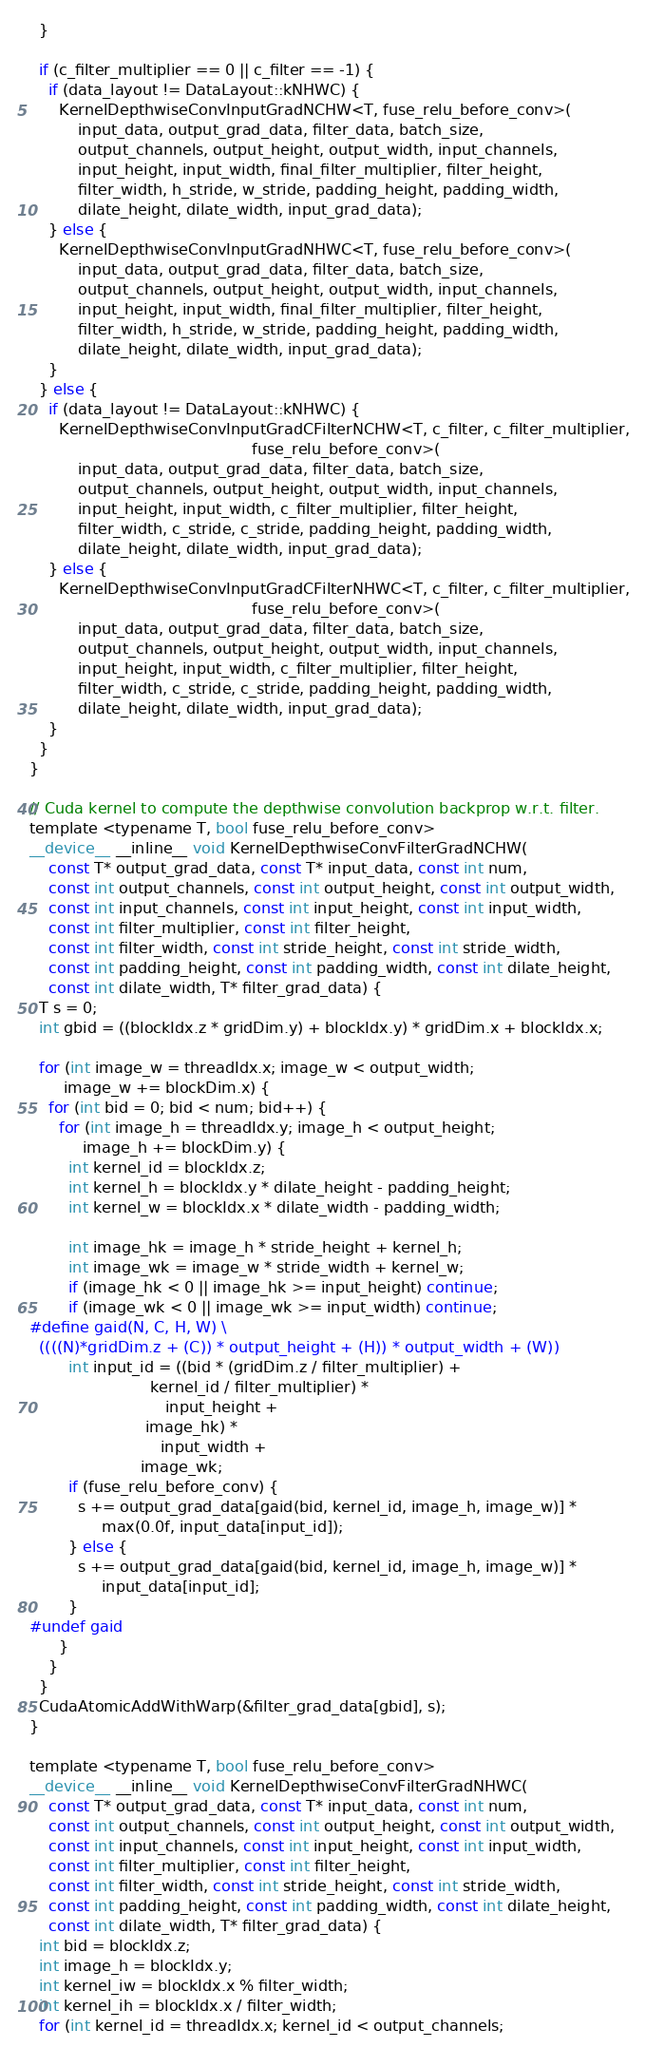<code> <loc_0><loc_0><loc_500><loc_500><_Cuda_>  }

  if (c_filter_multiplier == 0 || c_filter == -1) {
    if (data_layout != DataLayout::kNHWC) {
      KernelDepthwiseConvInputGradNCHW<T, fuse_relu_before_conv>(
          input_data, output_grad_data, filter_data, batch_size,
          output_channels, output_height, output_width, input_channels,
          input_height, input_width, final_filter_multiplier, filter_height,
          filter_width, h_stride, w_stride, padding_height, padding_width,
          dilate_height, dilate_width, input_grad_data);
    } else {
      KernelDepthwiseConvInputGradNHWC<T, fuse_relu_before_conv>(
          input_data, output_grad_data, filter_data, batch_size,
          output_channels, output_height, output_width, input_channels,
          input_height, input_width, final_filter_multiplier, filter_height,
          filter_width, h_stride, w_stride, padding_height, padding_width,
          dilate_height, dilate_width, input_grad_data);
    }
  } else {
    if (data_layout != DataLayout::kNHWC) {
      KernelDepthwiseConvInputGradCFilterNCHW<T, c_filter, c_filter_multiplier,
                                              fuse_relu_before_conv>(
          input_data, output_grad_data, filter_data, batch_size,
          output_channels, output_height, output_width, input_channels,
          input_height, input_width, c_filter_multiplier, filter_height,
          filter_width, c_stride, c_stride, padding_height, padding_width,
          dilate_height, dilate_width, input_grad_data);
    } else {
      KernelDepthwiseConvInputGradCFilterNHWC<T, c_filter, c_filter_multiplier,
                                              fuse_relu_before_conv>(
          input_data, output_grad_data, filter_data, batch_size,
          output_channels, output_height, output_width, input_channels,
          input_height, input_width, c_filter_multiplier, filter_height,
          filter_width, c_stride, c_stride, padding_height, padding_width,
          dilate_height, dilate_width, input_grad_data);
    }
  }
}

// Cuda kernel to compute the depthwise convolution backprop w.r.t. filter.
template <typename T, bool fuse_relu_before_conv>
__device__ __inline__ void KernelDepthwiseConvFilterGradNCHW(
    const T* output_grad_data, const T* input_data, const int num,
    const int output_channels, const int output_height, const int output_width,
    const int input_channels, const int input_height, const int input_width,
    const int filter_multiplier, const int filter_height,
    const int filter_width, const int stride_height, const int stride_width,
    const int padding_height, const int padding_width, const int dilate_height,
    const int dilate_width, T* filter_grad_data) {
  T s = 0;
  int gbid = ((blockIdx.z * gridDim.y) + blockIdx.y) * gridDim.x + blockIdx.x;

  for (int image_w = threadIdx.x; image_w < output_width;
       image_w += blockDim.x) {
    for (int bid = 0; bid < num; bid++) {
      for (int image_h = threadIdx.y; image_h < output_height;
           image_h += blockDim.y) {
        int kernel_id = blockIdx.z;
        int kernel_h = blockIdx.y * dilate_height - padding_height;
        int kernel_w = blockIdx.x * dilate_width - padding_width;

        int image_hk = image_h * stride_height + kernel_h;
        int image_wk = image_w * stride_width + kernel_w;
        if (image_hk < 0 || image_hk >= input_height) continue;
        if (image_wk < 0 || image_wk >= input_width) continue;
#define gaid(N, C, H, W) \
  ((((N)*gridDim.z + (C)) * output_height + (H)) * output_width + (W))
        int input_id = ((bid * (gridDim.z / filter_multiplier) +
                         kernel_id / filter_multiplier) *
                            input_height +
                        image_hk) *
                           input_width +
                       image_wk;
        if (fuse_relu_before_conv) {
          s += output_grad_data[gaid(bid, kernel_id, image_h, image_w)] *
               max(0.0f, input_data[input_id]);
        } else {
          s += output_grad_data[gaid(bid, kernel_id, image_h, image_w)] *
               input_data[input_id];
        }
#undef gaid
      }
    }
  }
  CudaAtomicAddWithWarp(&filter_grad_data[gbid], s);
}

template <typename T, bool fuse_relu_before_conv>
__device__ __inline__ void KernelDepthwiseConvFilterGradNHWC(
    const T* output_grad_data, const T* input_data, const int num,
    const int output_channels, const int output_height, const int output_width,
    const int input_channels, const int input_height, const int input_width,
    const int filter_multiplier, const int filter_height,
    const int filter_width, const int stride_height, const int stride_width,
    const int padding_height, const int padding_width, const int dilate_height,
    const int dilate_width, T* filter_grad_data) {
  int bid = blockIdx.z;
  int image_h = blockIdx.y;
  int kernel_iw = blockIdx.x % filter_width;
  int kernel_ih = blockIdx.x / filter_width;
  for (int kernel_id = threadIdx.x; kernel_id < output_channels;</code> 